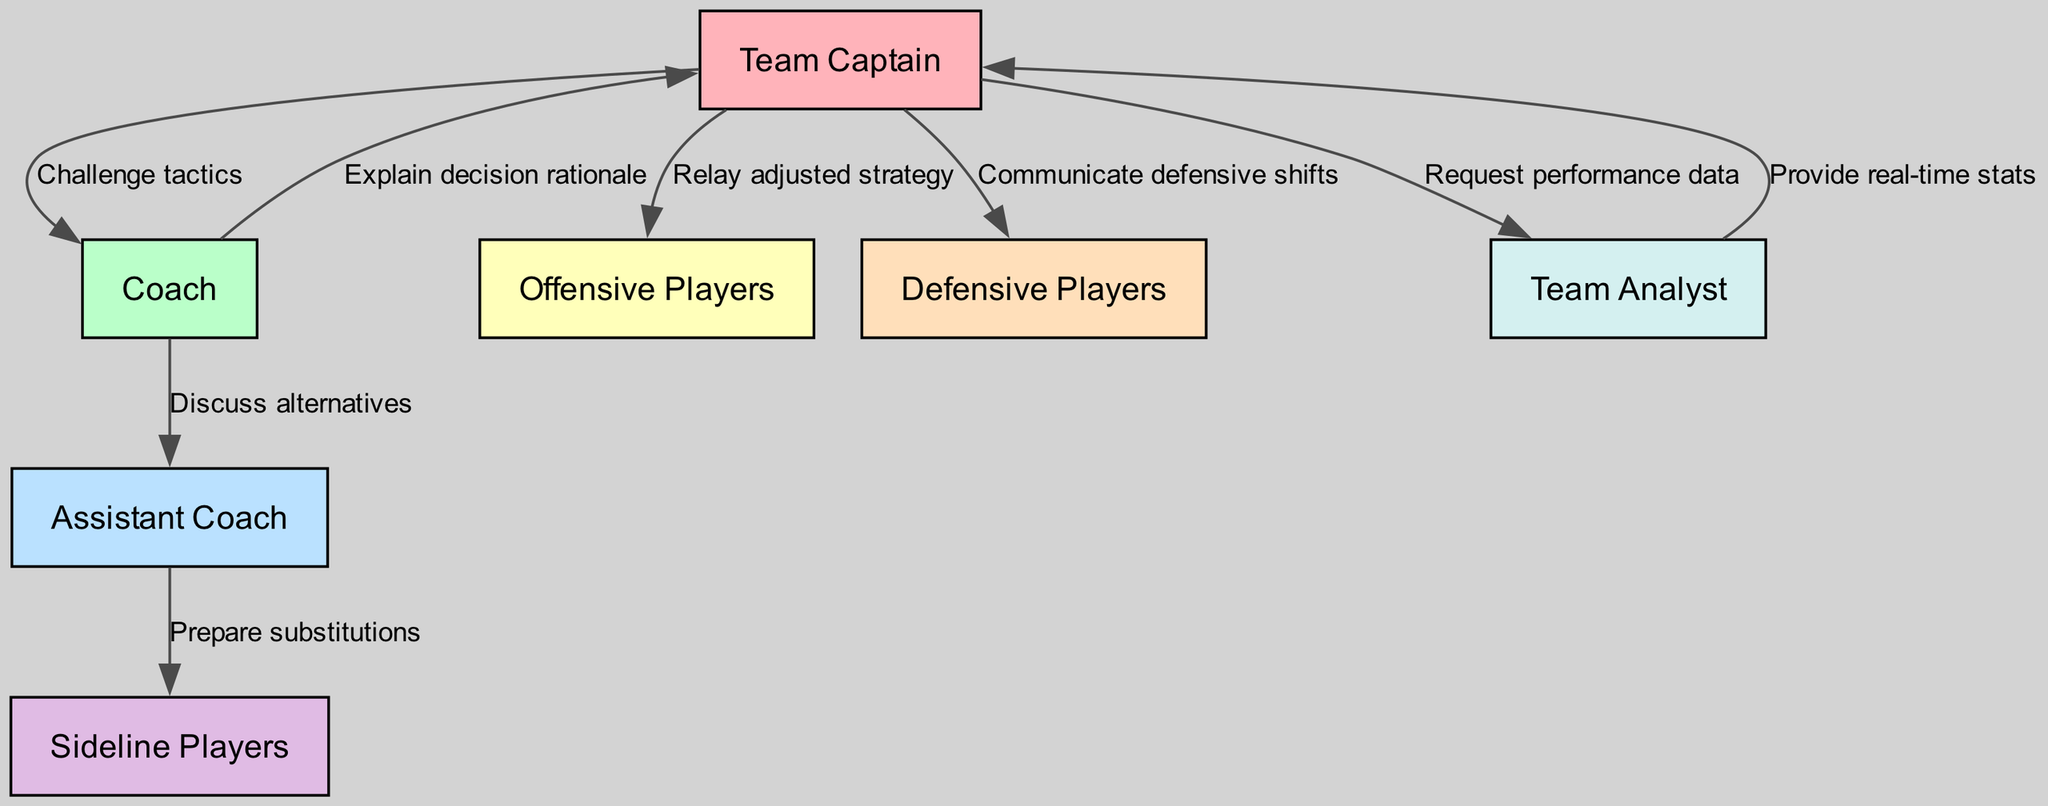What is the total number of nodes in the diagram? The diagram lists nodes representing different roles within the team: Team Captain, Coach, Assistant Coach, Offensive Players, Defensive Players, Sideline Players, and Team Analyst. Counting these gives us a total of 7 nodes.
Answer: 7 What is the relationship between the Team Captain and the Assistant Coach? The diagram shows no direct communication line between the Team Captain and the Assistant Coach; thus, there is no direct relationship indicated in the flowchart.
Answer: None Which node communicates real-time stats? The Team Analyst node is linked to the Team Captain node, providing real-time stats as part of the communication channels defined in the diagram.
Answer: Team Analyst How many edges connect the Coach to other nodes? From the diagram, the Coach node has two edges that connect to other nodes: to the Assistant Coach and the Team Captain. Counting these edges gives a total of 2.
Answer: 2 What do the edges from the Team Captain to Offensive Players represent? The edge labeled "Relay adjusted strategy" represents the communication from the Team Captain to the Offensive Players, indicating a way to relay tactical changes.
Answer: Relay adjusted strategy What is the primary function of the Team Analyst based on the diagram? The Team Analyst primarily provides real-time performance data, which is requested by the Team Captain and displayed in the flowchart as a directed edge.
Answer: Provide real-time stats Which role is tasked with preparing substitutions, according to the diagram? According to the diagram, the Assistant Coach is responsible for preparing substitutions, as indicated by the edge connecting it to Sideline Players.
Answer: Prepare substitutions What is the main flow of communication from the Team Captain to the Coach? The Team Captain communicates with the Coach by challenging tactics and also receives an explanation of the decision rationale in return, as evidenced by the edges connecting these nodes.
Answer: Challenge tactics, Explain decision rationale How many unique communication interactions involve the Team Captain? The Team Captain engages in multiple interactions: communicating with the Coach, Offensive Players, Defensive Players, and requesting data from the Team Analyst, which counts as 4 unique interactions.
Answer: 4 